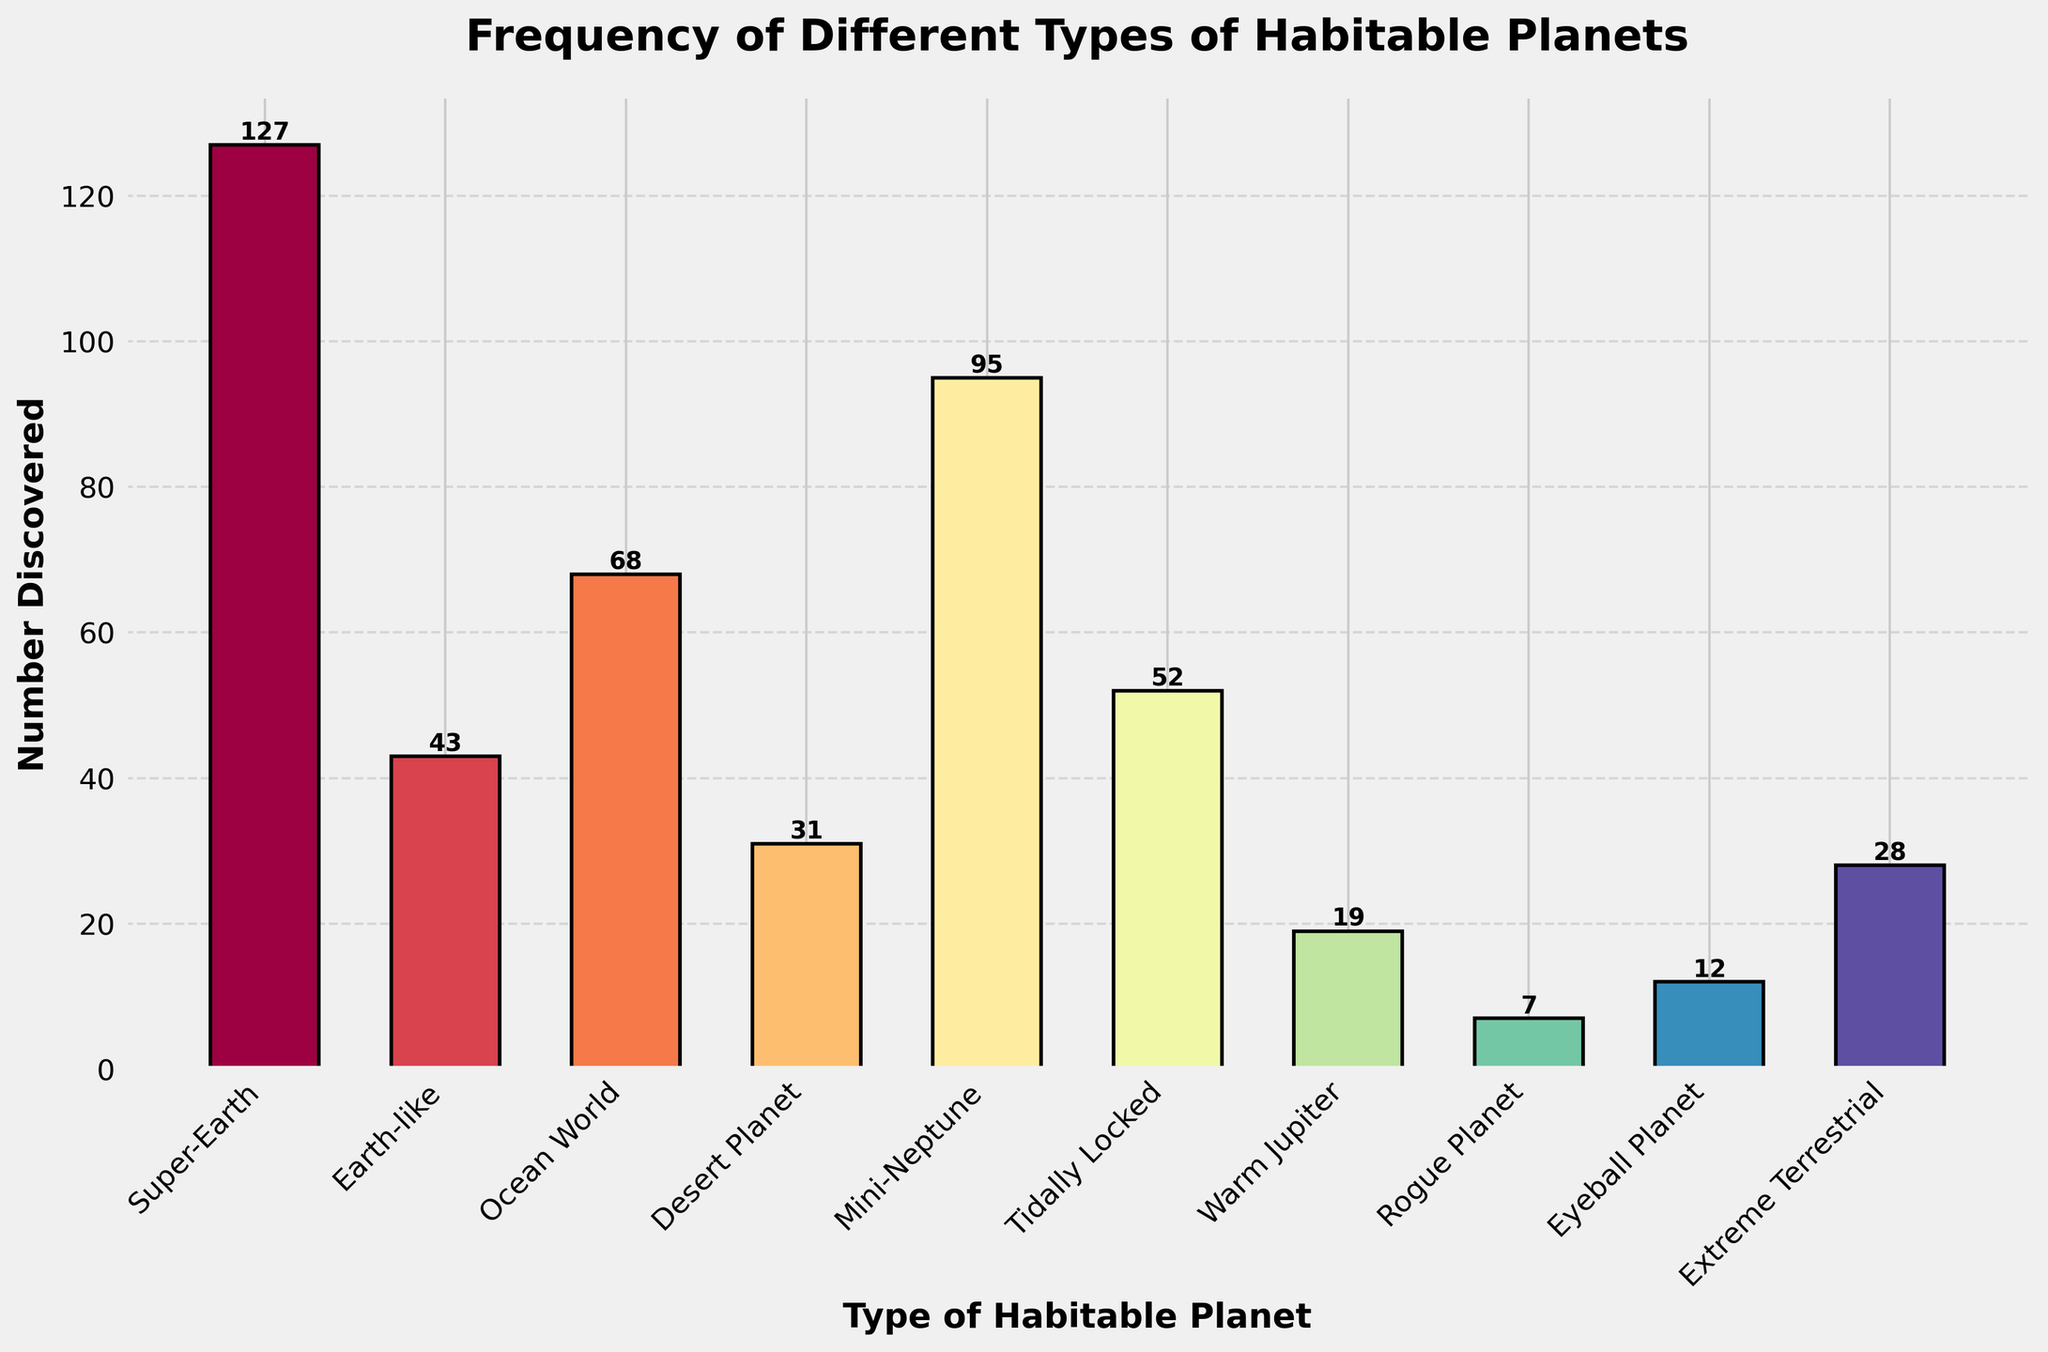Which type of habitable planet has been discovered the most? The type of habitable planet with the highest bar represents the most discovered type. The tallest bar corresponds to "Super-Earth".
Answer: Super-Earth How many Rogue Planets and Eyeball Planets have been discovered in total? Add the number of Rogue Planets (7) to the number of Eyeball Planets (12). 7 + 12 = 19
Answer: 19 Which type of habitable planet has been discovered more: Mini-Neptune or Ocean World? Compare the heights of the bars for Mini-Neptune and Ocean World. The bar for Mini-Neptune (95) is taller than that for Ocean World (68).
Answer: Mini-Neptune What is the difference in the number of discoveries between Earth-like and Extreme Terrestrial planets? Subtract the number of Extreme Terrestrial planets (28) from the number of Earth-like planets (43). 43 - 28 = 15
Answer: 15 How many types of habitable planets have fewer than 50 discoveries? Count the types of habitable planets with bars whose heights are below the 50 mark. These are Desert Planet (31), Rogue Planet (7), Eyeball Planet (12), Extreme Terrestrial (28), and Warm Jupiter (19). There are 5 of them.
Answer: 5 What is the sum of discoveries for Super-Earth and Desert Planet? Add the number of Super-Earth (127) discoveries to that of Desert Planet (31). 127 + 31 = 158
Answer: 158 Which planet type has the least number of discoveries? The shortest bar on the chart corresponds to Rogue Planet with 7 discoveries.
Answer: Rogue Planet Which type of habitable planet has approximately twice the number of discoveries as Earth-like planets? Double the number of Earth-like planets (43), which is 86. Mini-Neptune has 95 discoveries, which is closest to this value.
Answer: Mini-Neptune How many more Tidally Locked planets have been discovered compared to Warm Jupiters? Subtract the number of Warm Jupiters (19) from Tidally Locked planets (52). 52 - 19 = 33
Answer: 33 What’s the average number of discoveries for Desert Planet, Eyeball Planet, and Extreme Terrestrial? Add the number of discoveries for Desert Planet (31), Eyeball Planet (12), and Extreme Terrestrial (28) and divide by 3. 31 + 12 + 28 = 71; 71 / 3 ≈ 23.67
Answer: 23.67 